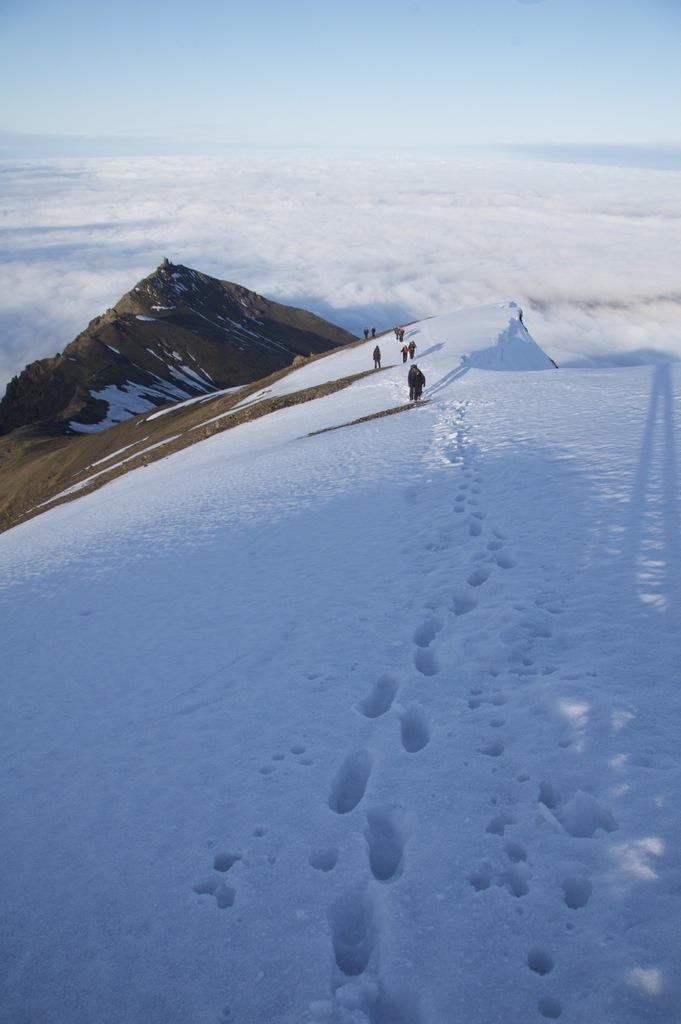Who or what is present in the image? There are people in the image. What is the surface on which the people are standing? The people are on snow. What can be seen in the distance behind the people? There is a mountain in the background of the image. What else is visible in the background of the image? The sky is visible in the background of the image. What type of pen is being used by the people in the image? There is no pen present in the image. What news is being discussed by the people in the image? There is no indication of a discussion or news in the image. 